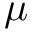<formula> <loc_0><loc_0><loc_500><loc_500>\mu</formula> 